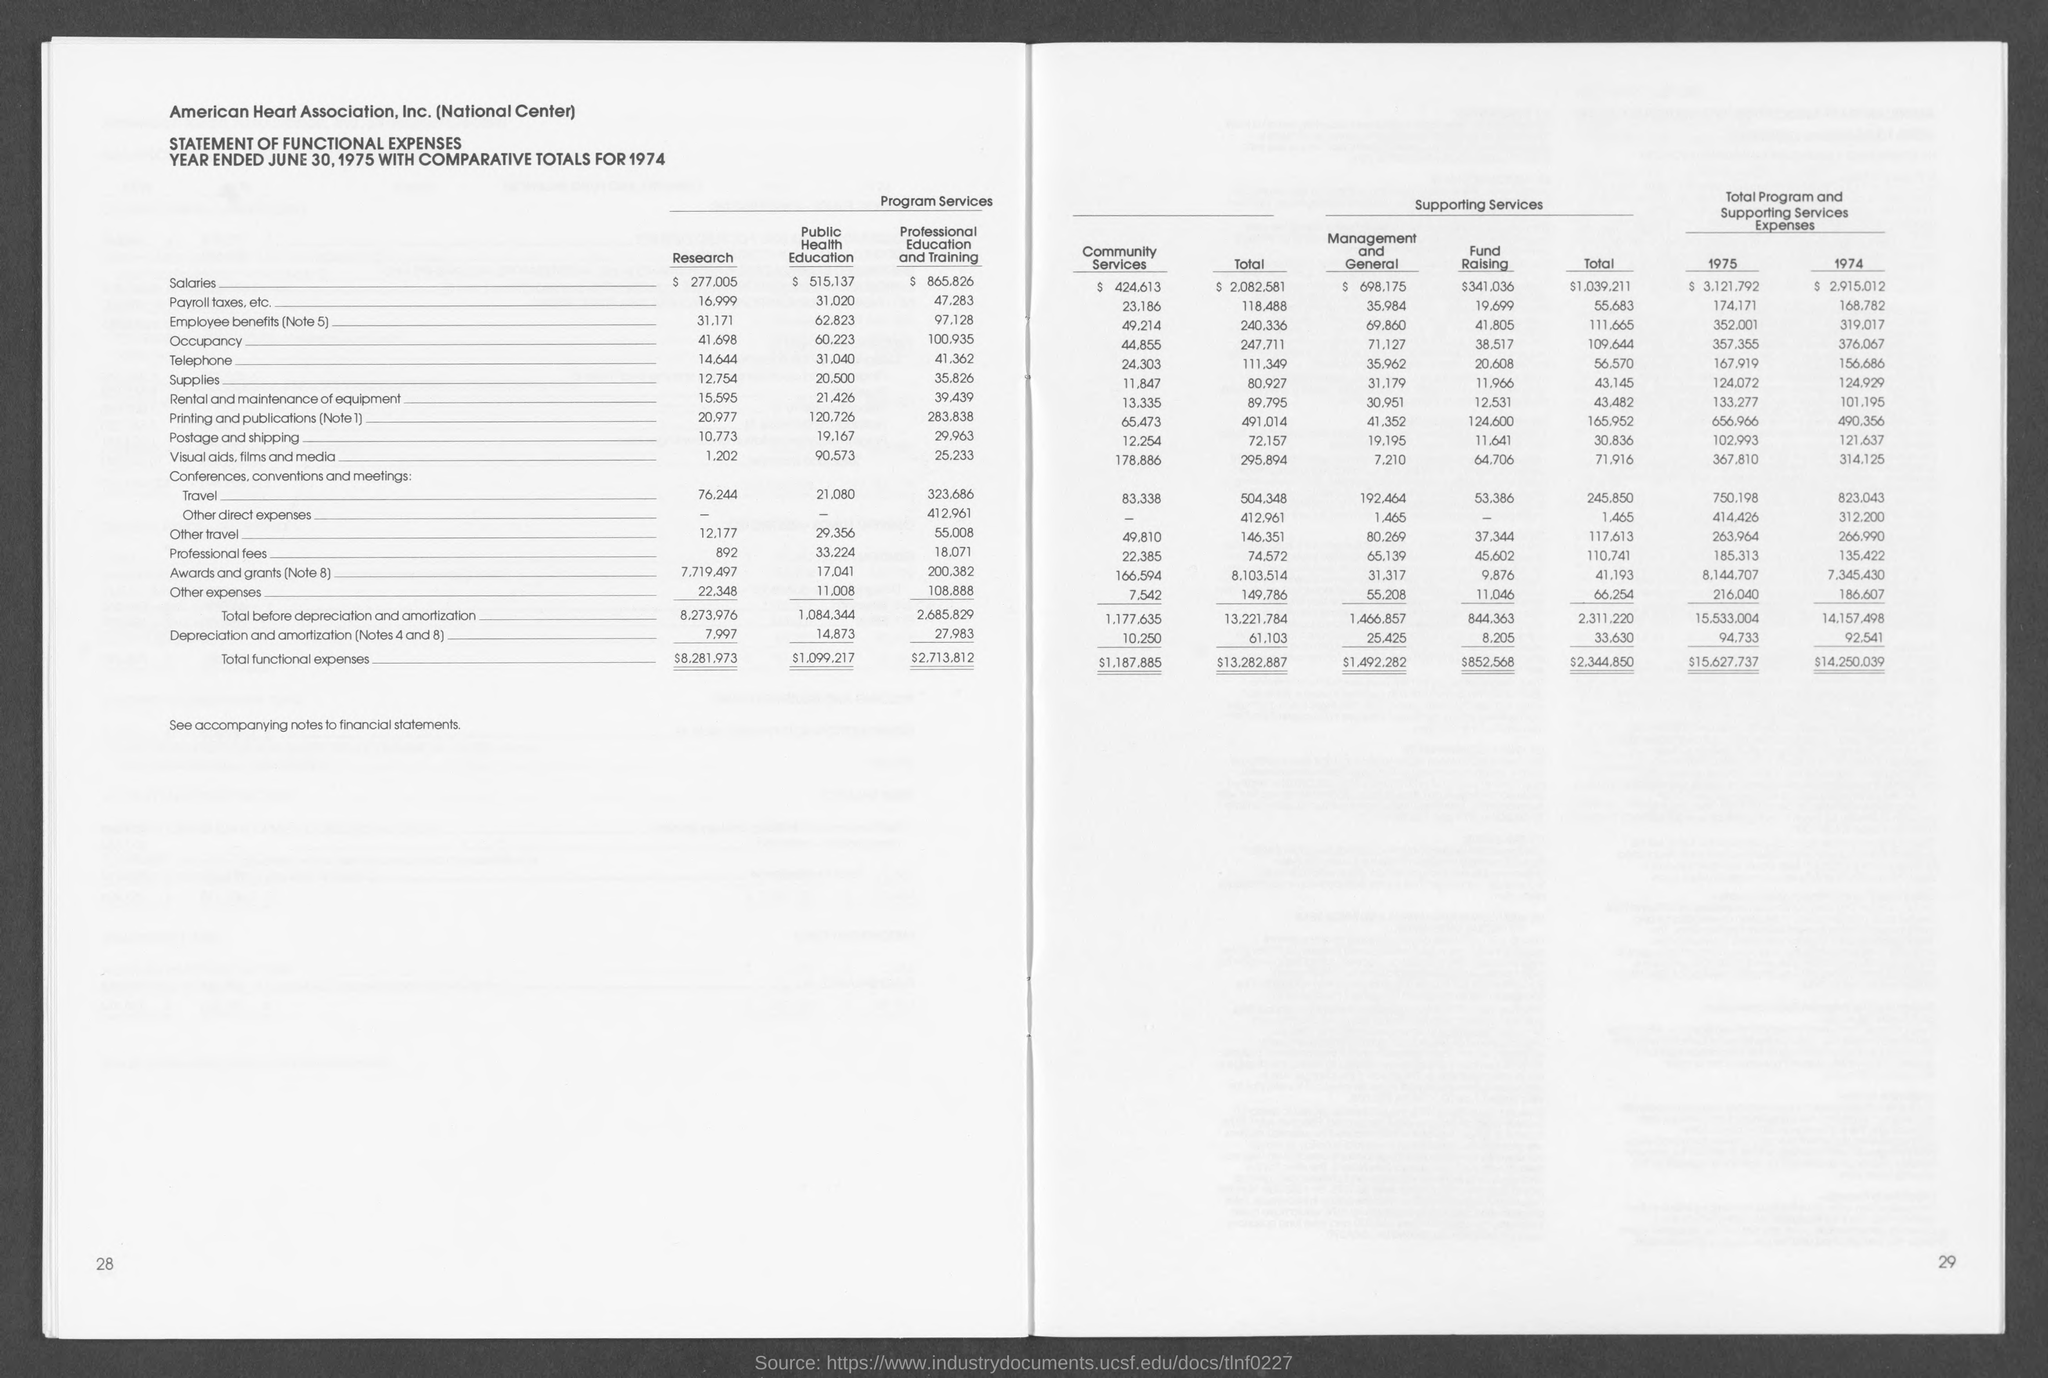Specify some key components in this picture. The name of the association is the AMERICAN HEART ASSOCIATION, INC. (NATIONAL CENTER). The entry for "Total functional expenses" under the column named "Research" is $8,281,973. On June 30, 1975, the date was given as the year-end. 